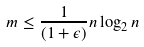Convert formula to latex. <formula><loc_0><loc_0><loc_500><loc_500>m \leq \frac { 1 } { ( 1 + \epsilon ) } n \log _ { 2 } n</formula> 